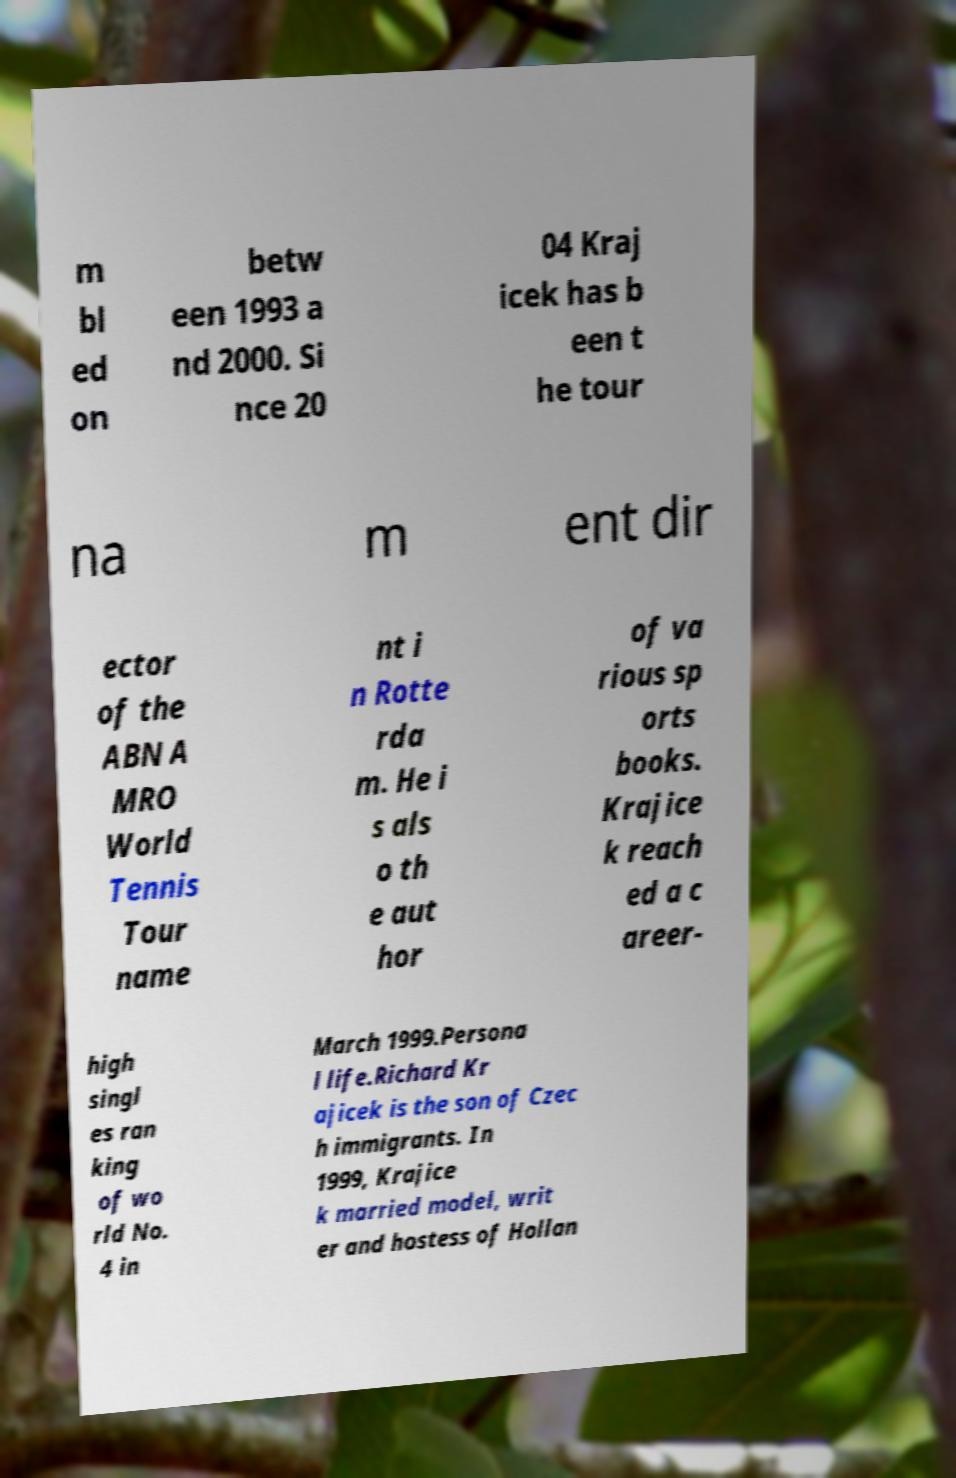Can you read and provide the text displayed in the image?This photo seems to have some interesting text. Can you extract and type it out for me? m bl ed on betw een 1993 a nd 2000. Si nce 20 04 Kraj icek has b een t he tour na m ent dir ector of the ABN A MRO World Tennis Tour name nt i n Rotte rda m. He i s als o th e aut hor of va rious sp orts books. Krajice k reach ed a c areer- high singl es ran king of wo rld No. 4 in March 1999.Persona l life.Richard Kr ajicek is the son of Czec h immigrants. In 1999, Krajice k married model, writ er and hostess of Hollan 